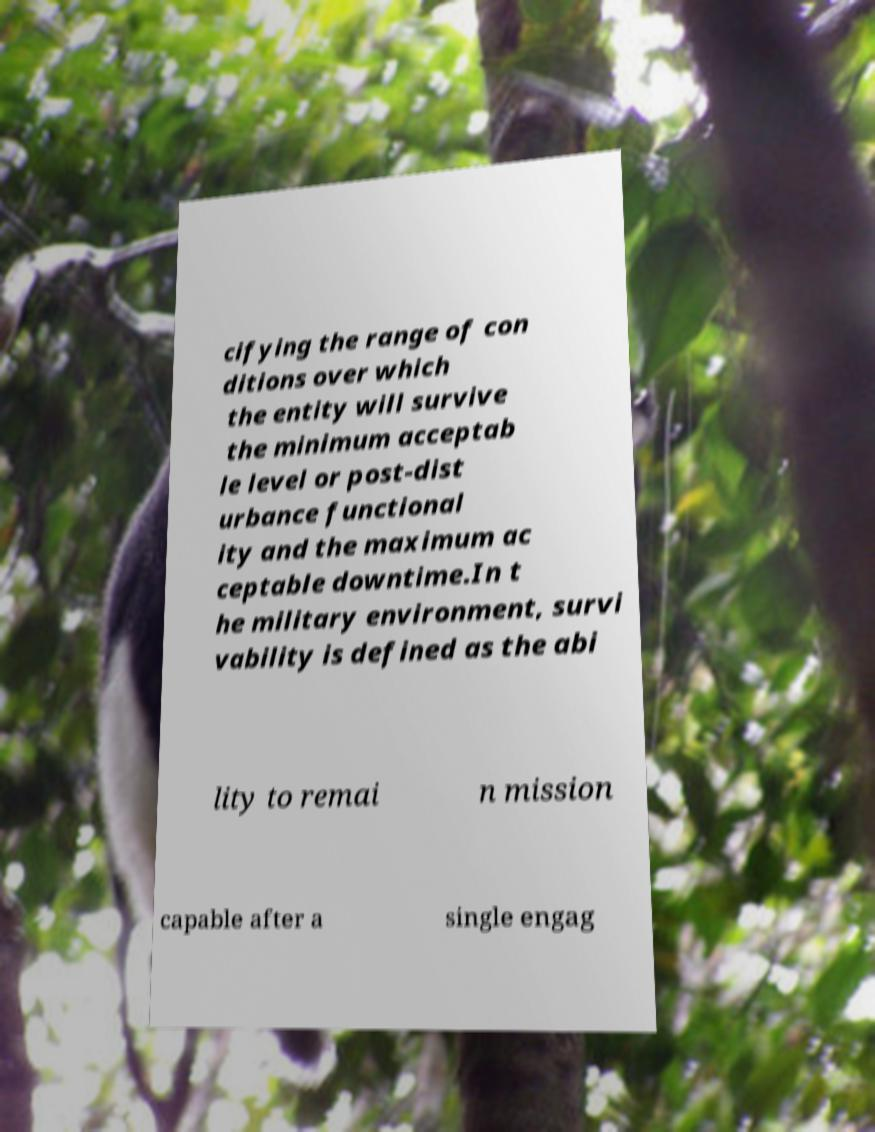There's text embedded in this image that I need extracted. Can you transcribe it verbatim? cifying the range of con ditions over which the entity will survive the minimum acceptab le level or post-dist urbance functional ity and the maximum ac ceptable downtime.In t he military environment, survi vability is defined as the abi lity to remai n mission capable after a single engag 